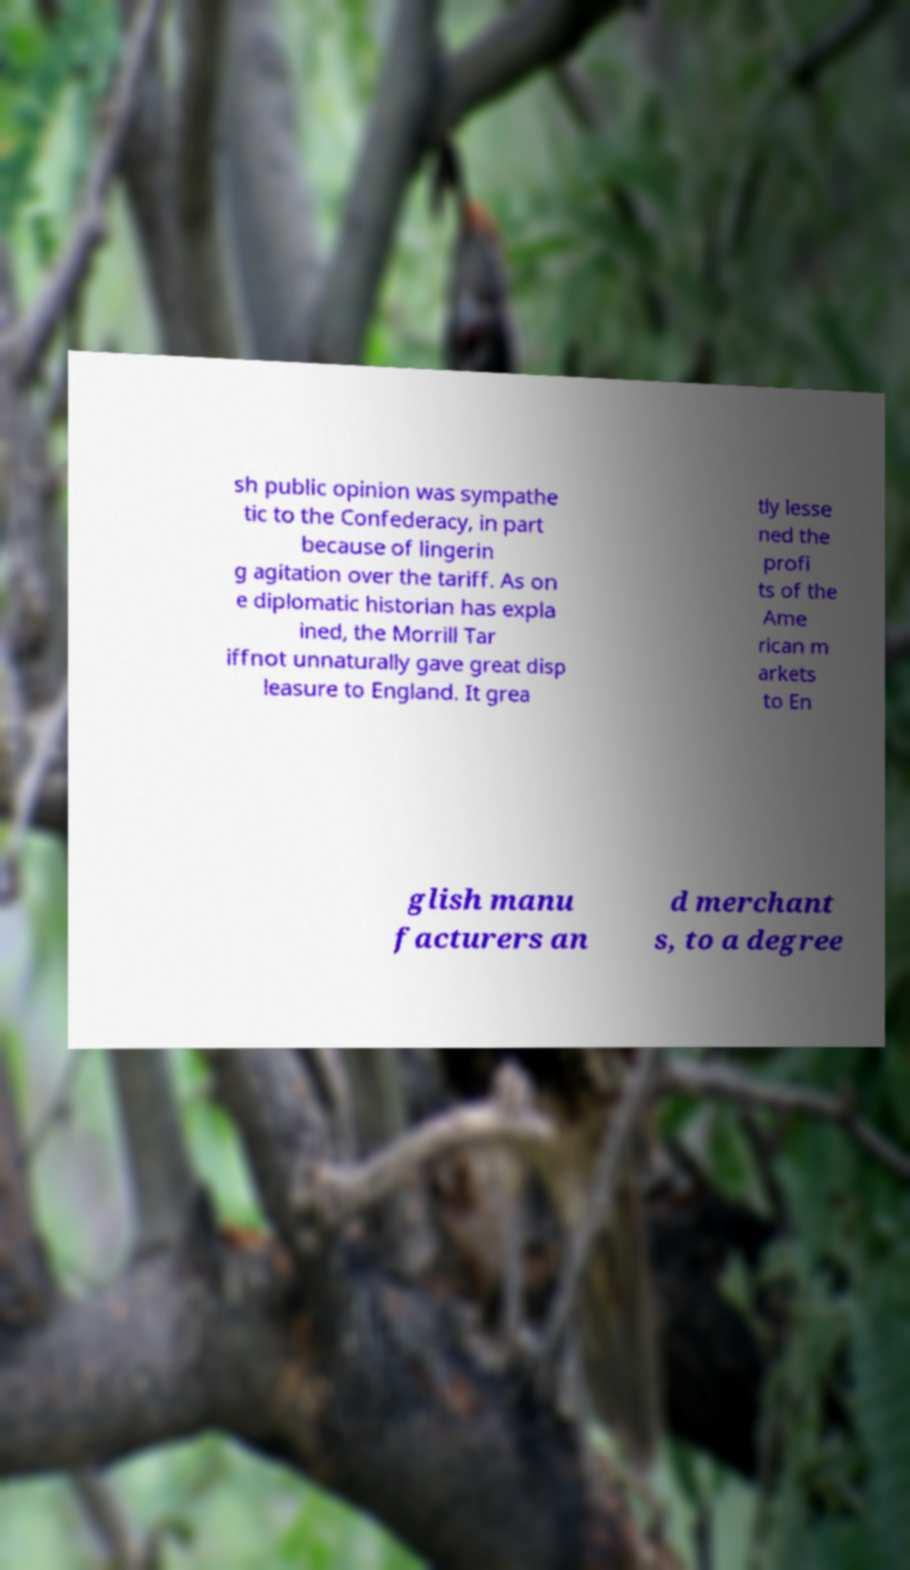What messages or text are displayed in this image? I need them in a readable, typed format. sh public opinion was sympathe tic to the Confederacy, in part because of lingerin g agitation over the tariff. As on e diplomatic historian has expla ined, the Morrill Tar iffnot unnaturally gave great disp leasure to England. It grea tly lesse ned the profi ts of the Ame rican m arkets to En glish manu facturers an d merchant s, to a degree 